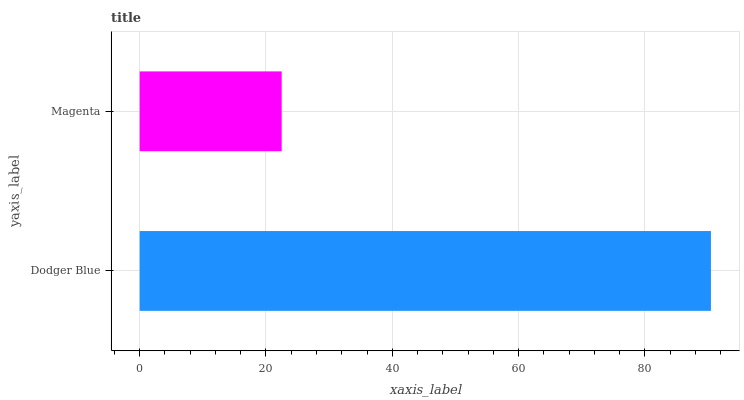Is Magenta the minimum?
Answer yes or no. Yes. Is Dodger Blue the maximum?
Answer yes or no. Yes. Is Magenta the maximum?
Answer yes or no. No. Is Dodger Blue greater than Magenta?
Answer yes or no. Yes. Is Magenta less than Dodger Blue?
Answer yes or no. Yes. Is Magenta greater than Dodger Blue?
Answer yes or no. No. Is Dodger Blue less than Magenta?
Answer yes or no. No. Is Dodger Blue the high median?
Answer yes or no. Yes. Is Magenta the low median?
Answer yes or no. Yes. Is Magenta the high median?
Answer yes or no. No. Is Dodger Blue the low median?
Answer yes or no. No. 